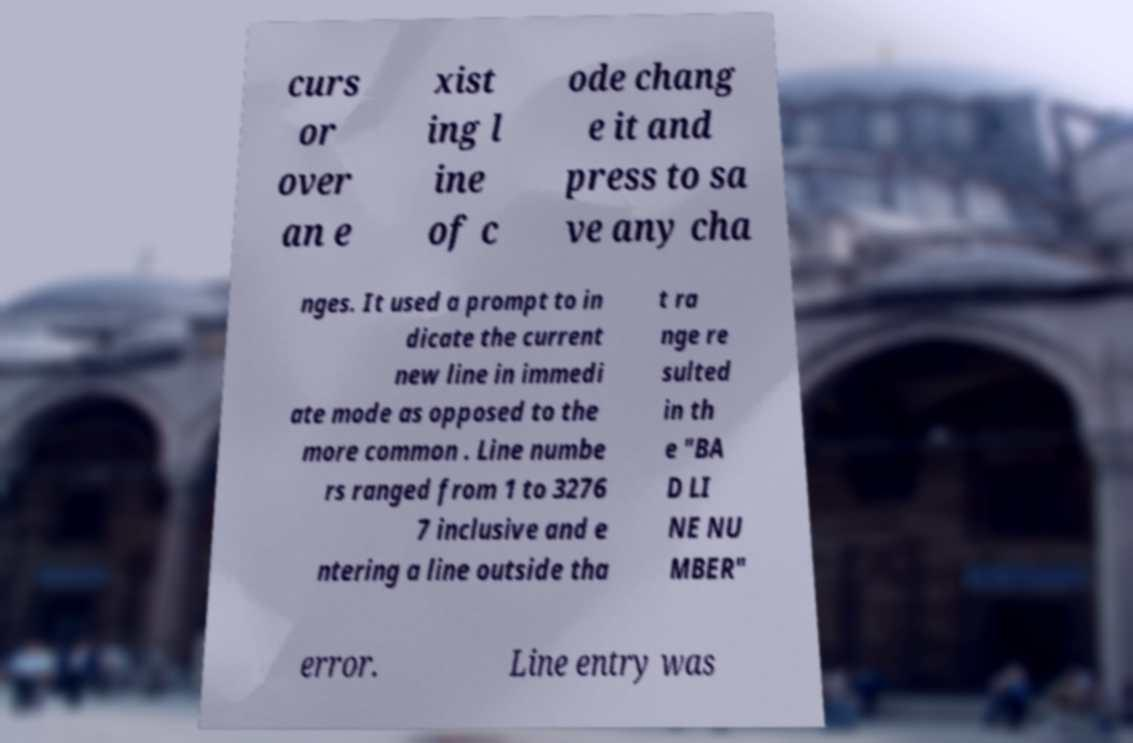Please identify and transcribe the text found in this image. curs or over an e xist ing l ine of c ode chang e it and press to sa ve any cha nges. It used a prompt to in dicate the current new line in immedi ate mode as opposed to the more common . Line numbe rs ranged from 1 to 3276 7 inclusive and e ntering a line outside tha t ra nge re sulted in th e "BA D LI NE NU MBER" error. Line entry was 